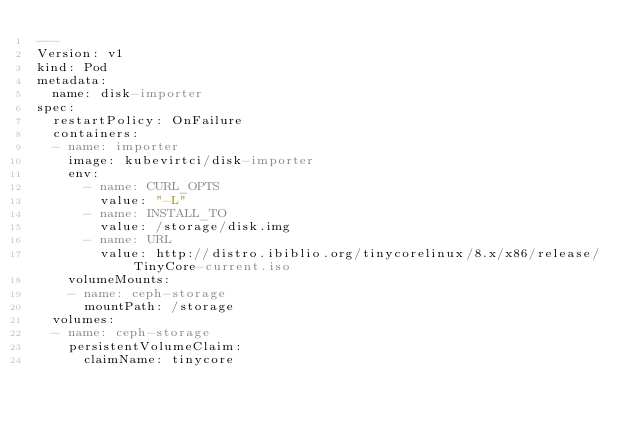Convert code to text. <code><loc_0><loc_0><loc_500><loc_500><_YAML_>---
Version: v1
kind: Pod
metadata:
  name: disk-importer
spec:
  restartPolicy: OnFailure
  containers:
  - name: importer
    image: kubevirtci/disk-importer
    env:
      - name: CURL_OPTS
        value: "-L"
      - name: INSTALL_TO
        value: /storage/disk.img
      - name: URL
        value: http://distro.ibiblio.org/tinycorelinux/8.x/x86/release/TinyCore-current.iso
    volumeMounts:
    - name: ceph-storage
      mountPath: /storage
  volumes:
  - name: ceph-storage
    persistentVolumeClaim:
      claimName: tinycore
</code> 